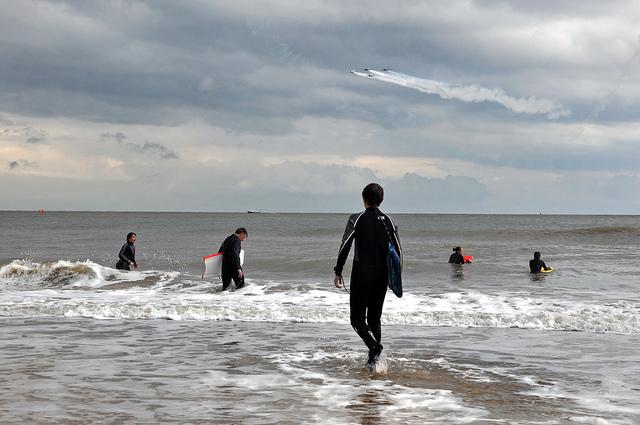What's the weather like?
Be succinct. Cloudy. How many people?
Short answer required. 5. What are the people doing?
Concise answer only. Surfing. Are the people in the ocean?
Keep it brief. Yes. 